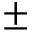<formula> <loc_0><loc_0><loc_500><loc_500>\pm</formula> 